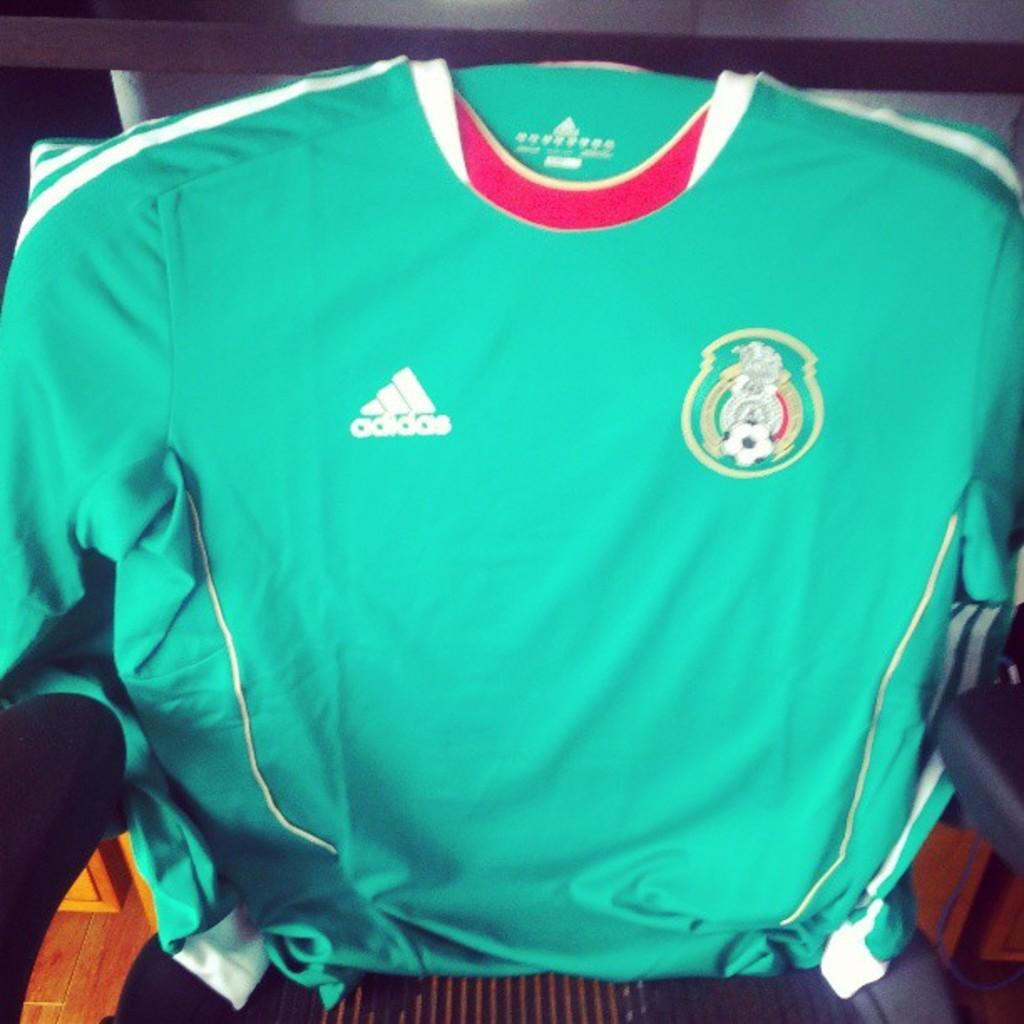<image>
Give a short and clear explanation of the subsequent image. A Mexico jersey with the name Adidas on it 